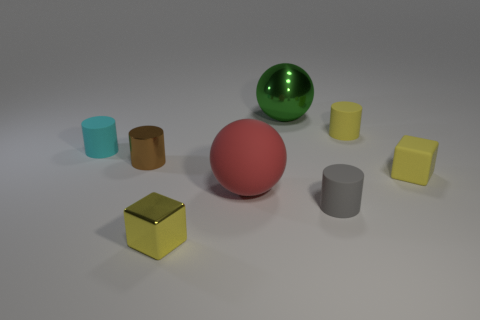Subtract all tiny yellow cylinders. How many cylinders are left? 3 Subtract all red balls. How many balls are left? 1 Subtract all cubes. How many objects are left? 6 Subtract all green cylinders. How many green balls are left? 1 Add 2 gray matte objects. How many objects exist? 10 Subtract 2 cubes. How many cubes are left? 0 Subtract all gray cylinders. Subtract all yellow cubes. How many cylinders are left? 3 Subtract all tiny yellow balls. Subtract all tiny yellow matte things. How many objects are left? 6 Add 5 small brown things. How many small brown things are left? 6 Add 2 green objects. How many green objects exist? 3 